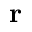Convert formula to latex. <formula><loc_0><loc_0><loc_500><loc_500>r</formula> 